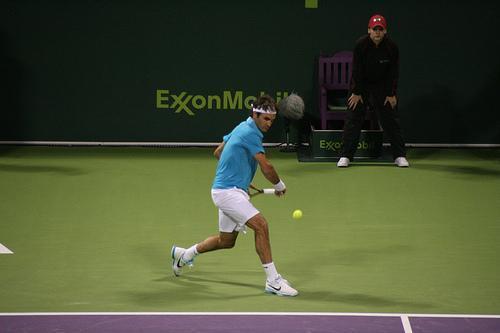How many people are there?
Give a very brief answer. 2. 